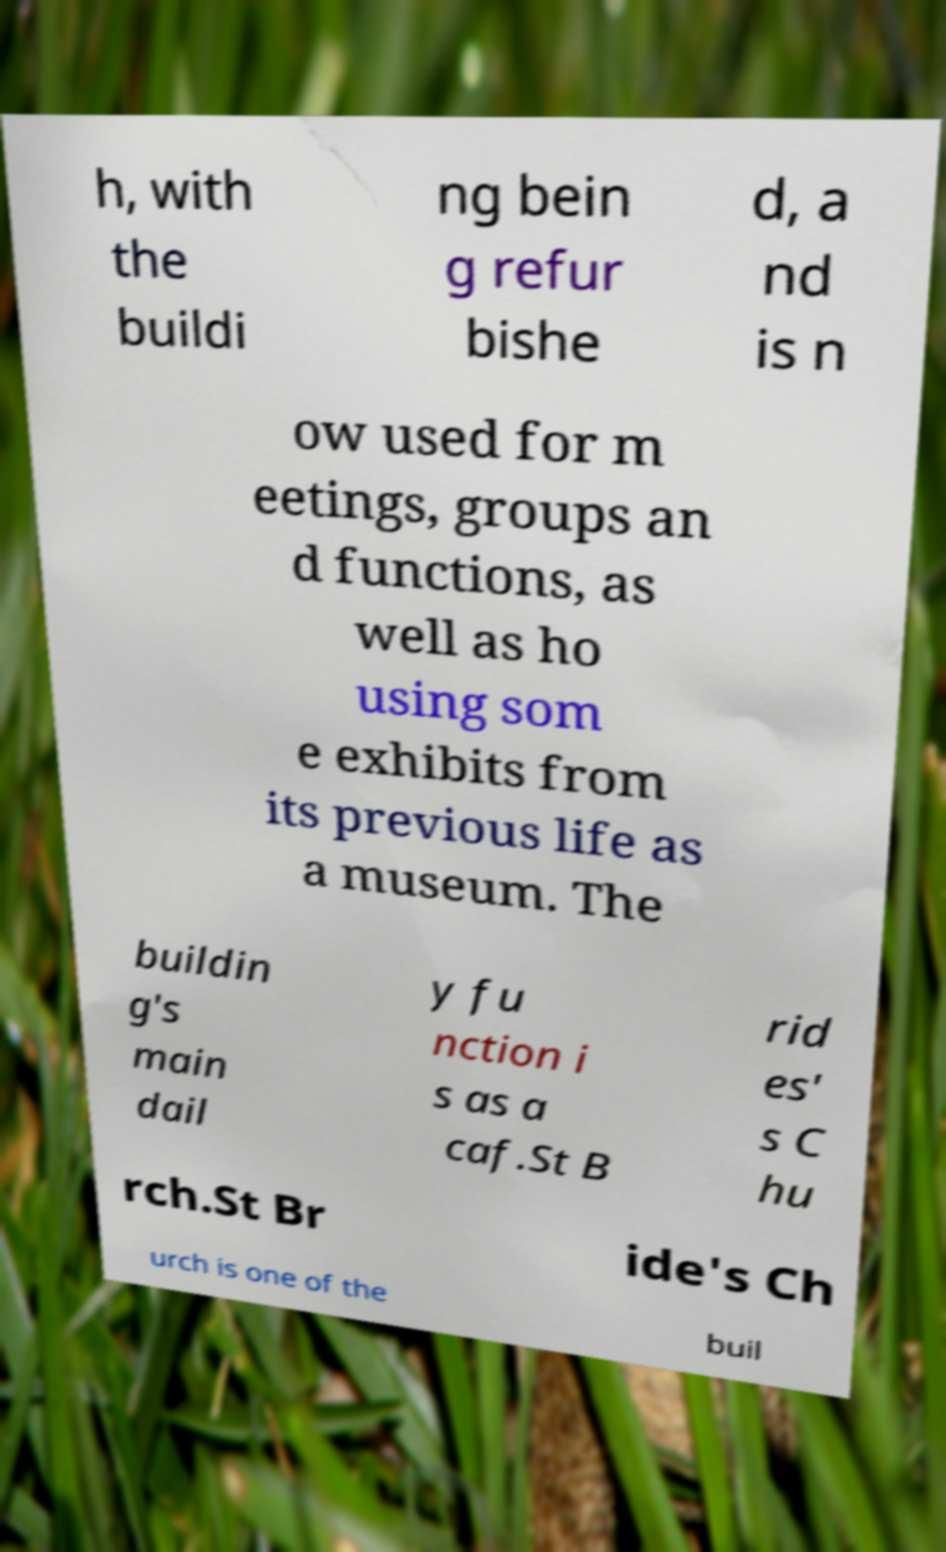Could you assist in decoding the text presented in this image and type it out clearly? h, with the buildi ng bein g refur bishe d, a nd is n ow used for m eetings, groups an d functions, as well as ho using som e exhibits from its previous life as a museum. The buildin g's main dail y fu nction i s as a caf.St B rid es' s C hu rch.St Br ide's Ch urch is one of the buil 